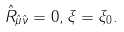Convert formula to latex. <formula><loc_0><loc_0><loc_500><loc_500>\hat { R } _ { \hat { \mu } \hat { \nu } } = 0 , \xi = \xi _ { 0 } .</formula> 